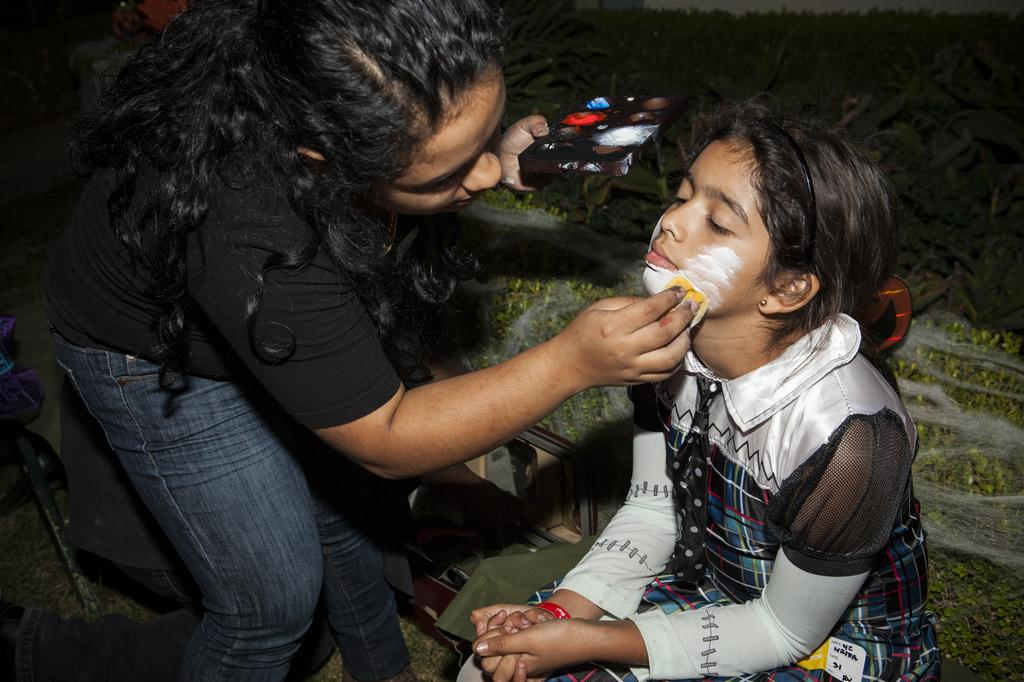How many people are in the image? There are two people in the image. What are the two people doing in the image? One person is putting face paint on the other person. What can be seen in the background of the image? There are plants visible in the background of the image. What type of silk material is draped over the sheet in the image? There is no sheet or silk material present in the image. 